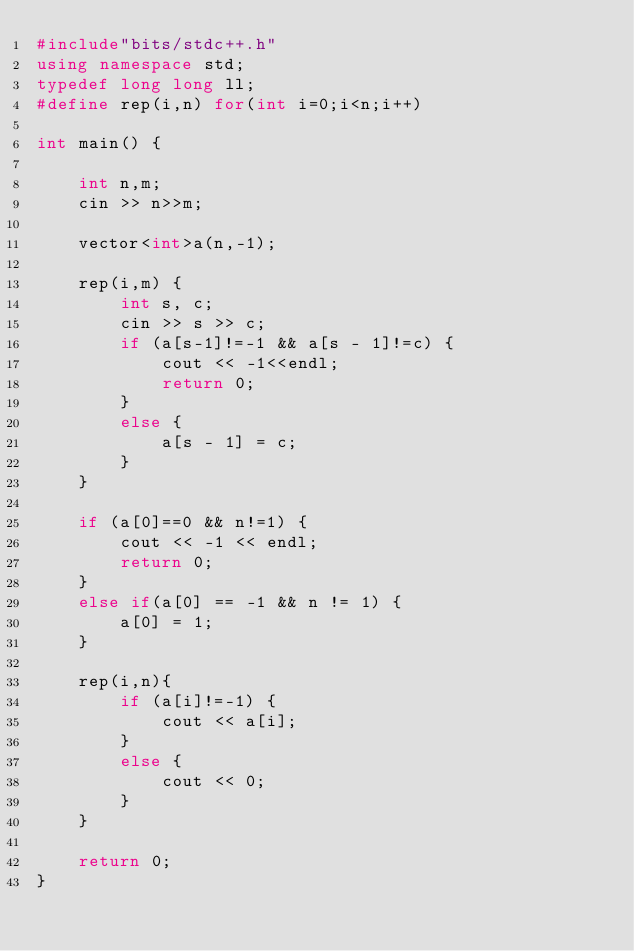<code> <loc_0><loc_0><loc_500><loc_500><_C++_>#include"bits/stdc++.h"
using namespace std;
typedef long long ll;
#define rep(i,n) for(int i=0;i<n;i++)

int main() {
	
	int n,m;
	cin >> n>>m;

	vector<int>a(n,-1);

	rep(i,m) {
		int s, c;
		cin >> s >> c;
		if (a[s-1]!=-1 && a[s - 1]!=c) {
			cout << -1<<endl;
			return 0;
		}
		else {
			a[s - 1] = c;
		}
	}

	if (a[0]==0 && n!=1) {
		cout << -1 << endl;
		return 0;
	}
	else if(a[0] == -1 && n != 1) {
		a[0] = 1;
	}

	rep(i,n){
		if (a[i]!=-1) {
			cout << a[i];
		}
		else {
			cout << 0;
		}
	}

	return 0;
}
</code> 